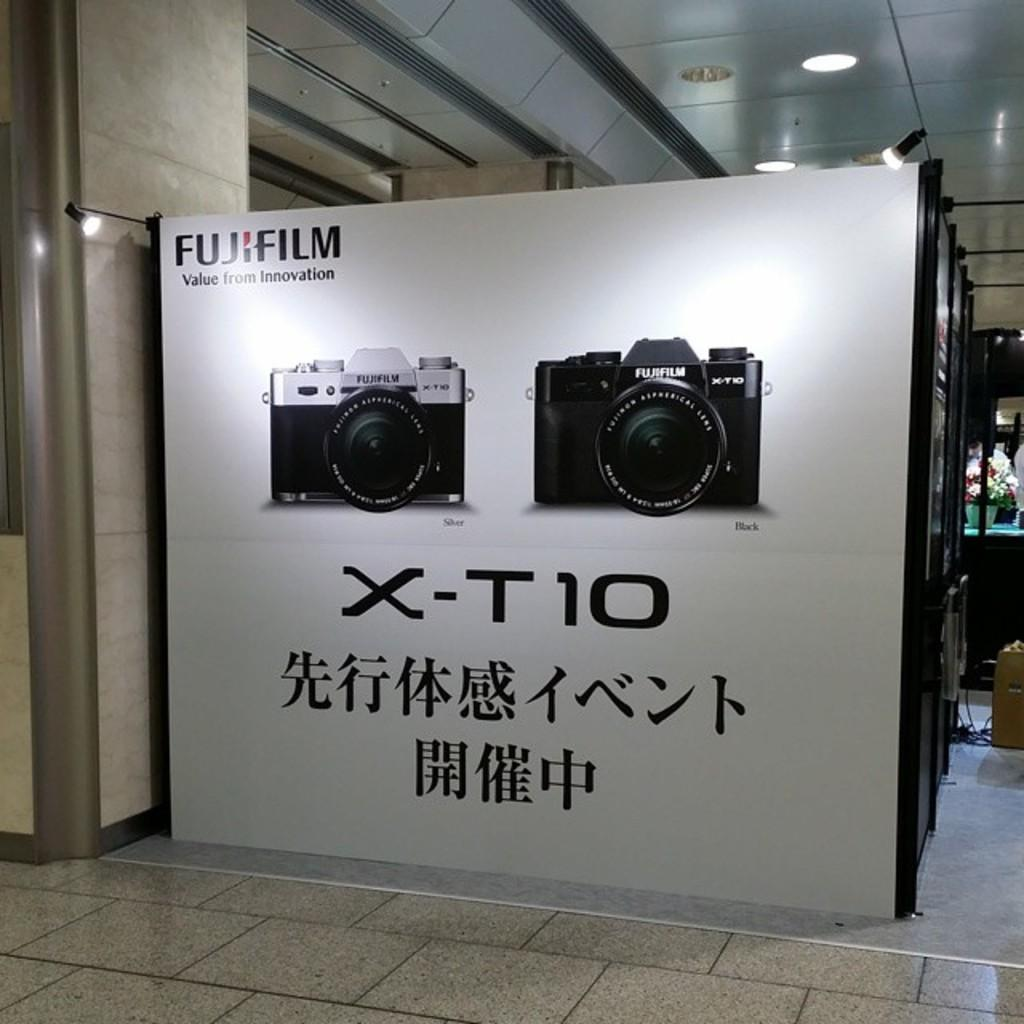<image>
Offer a succinct explanation of the picture presented. A wall-sized Fujifilm advertisement shows a new X-T10 camera. 